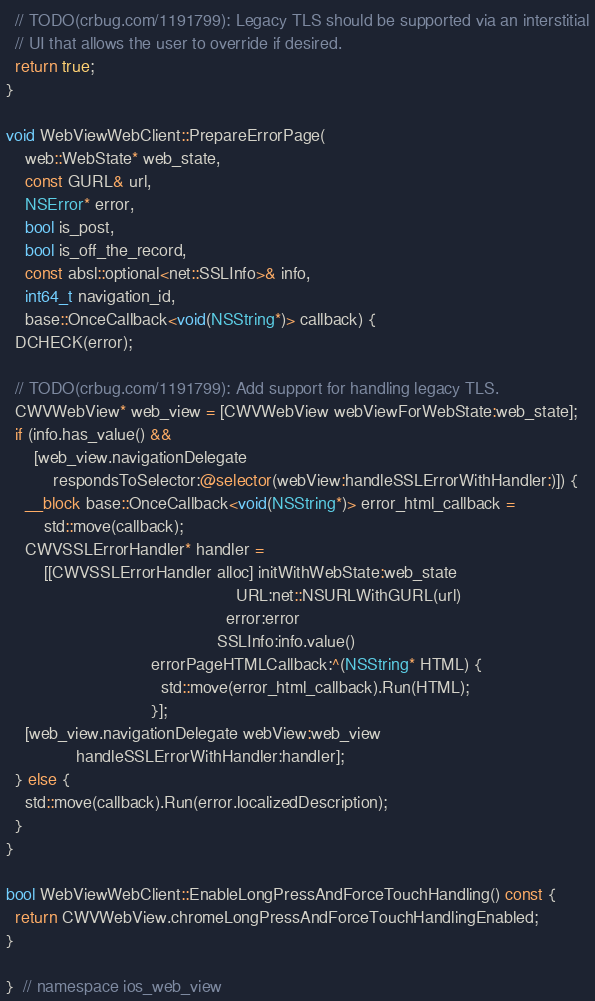Convert code to text. <code><loc_0><loc_0><loc_500><loc_500><_ObjectiveC_>  // TODO(crbug.com/1191799): Legacy TLS should be supported via an interstitial
  // UI that allows the user to override if desired.
  return true;
}

void WebViewWebClient::PrepareErrorPage(
    web::WebState* web_state,
    const GURL& url,
    NSError* error,
    bool is_post,
    bool is_off_the_record,
    const absl::optional<net::SSLInfo>& info,
    int64_t navigation_id,
    base::OnceCallback<void(NSString*)> callback) {
  DCHECK(error);

  // TODO(crbug.com/1191799): Add support for handling legacy TLS.
  CWVWebView* web_view = [CWVWebView webViewForWebState:web_state];
  if (info.has_value() &&
      [web_view.navigationDelegate
          respondsToSelector:@selector(webView:handleSSLErrorWithHandler:)]) {
    __block base::OnceCallback<void(NSString*)> error_html_callback =
        std::move(callback);
    CWVSSLErrorHandler* handler =
        [[CWVSSLErrorHandler alloc] initWithWebState:web_state
                                                 URL:net::NSURLWithGURL(url)
                                               error:error
                                             SSLInfo:info.value()
                               errorPageHTMLCallback:^(NSString* HTML) {
                                 std::move(error_html_callback).Run(HTML);
                               }];
    [web_view.navigationDelegate webView:web_view
               handleSSLErrorWithHandler:handler];
  } else {
    std::move(callback).Run(error.localizedDescription);
  }
}

bool WebViewWebClient::EnableLongPressAndForceTouchHandling() const {
  return CWVWebView.chromeLongPressAndForceTouchHandlingEnabled;
}

}  // namespace ios_web_view
</code> 